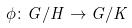<formula> <loc_0><loc_0><loc_500><loc_500>\phi \colon G / H \rightarrow G / K</formula> 